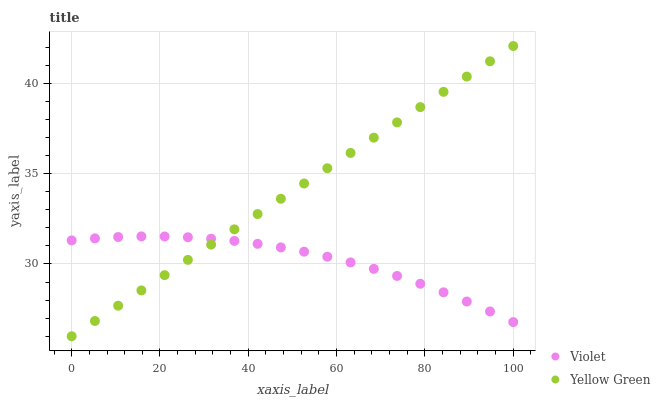Does Violet have the minimum area under the curve?
Answer yes or no. Yes. Does Yellow Green have the maximum area under the curve?
Answer yes or no. Yes. Does Violet have the maximum area under the curve?
Answer yes or no. No. Is Yellow Green the smoothest?
Answer yes or no. Yes. Is Violet the roughest?
Answer yes or no. Yes. Is Violet the smoothest?
Answer yes or no. No. Does Yellow Green have the lowest value?
Answer yes or no. Yes. Does Violet have the lowest value?
Answer yes or no. No. Does Yellow Green have the highest value?
Answer yes or no. Yes. Does Violet have the highest value?
Answer yes or no. No. Does Violet intersect Yellow Green?
Answer yes or no. Yes. Is Violet less than Yellow Green?
Answer yes or no. No. Is Violet greater than Yellow Green?
Answer yes or no. No. 